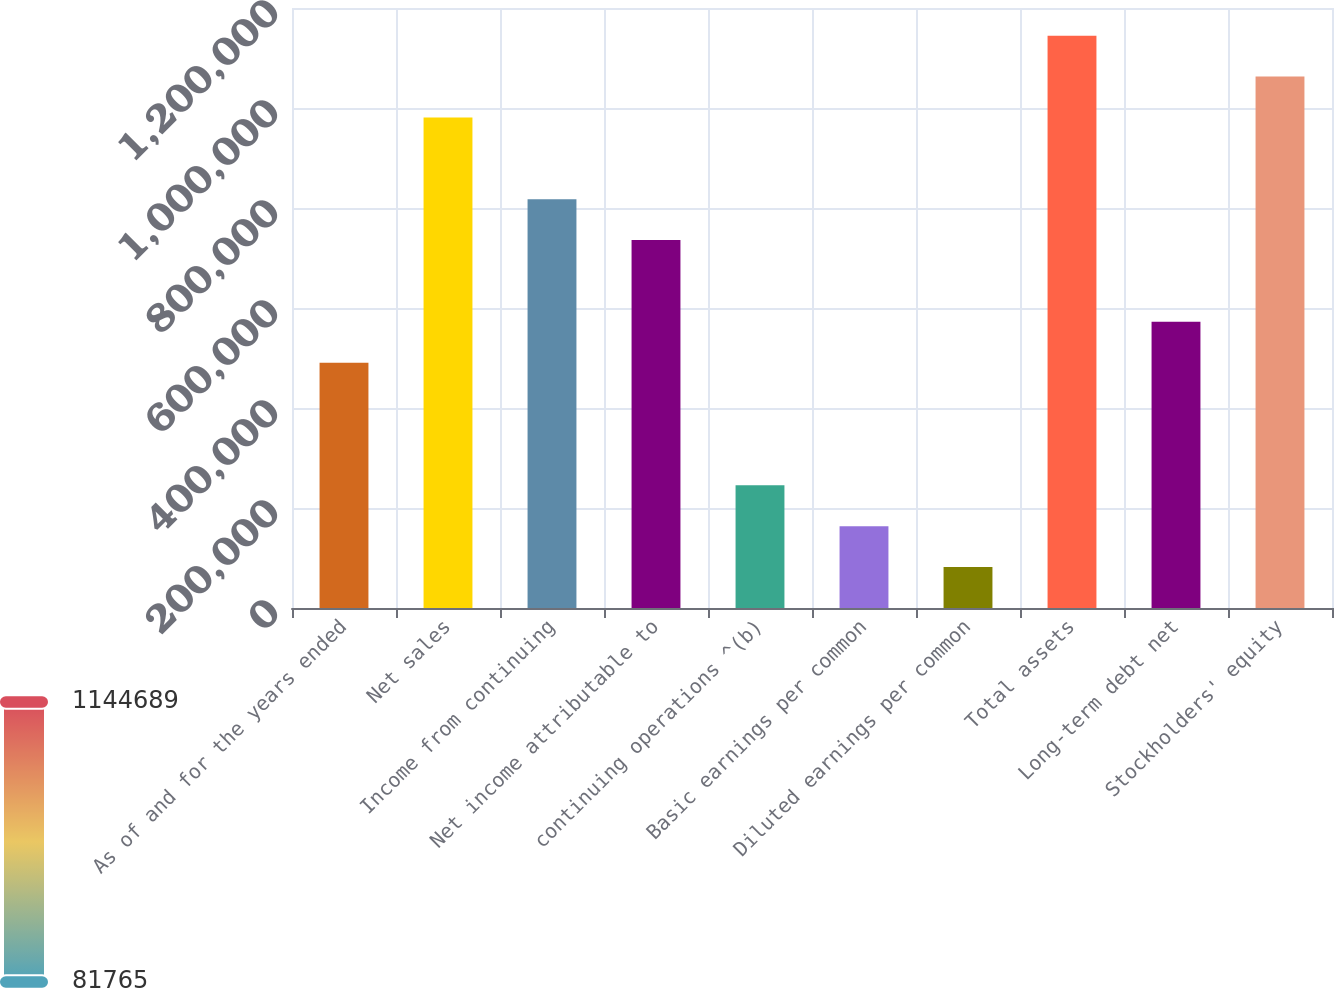<chart> <loc_0><loc_0><loc_500><loc_500><bar_chart><fcel>As of and for the years ended<fcel>Net sales<fcel>Income from continuing<fcel>Net income attributable to<fcel>continuing operations ^(b)<fcel>Basic earnings per common<fcel>Diluted earnings per common<fcel>Total assets<fcel>Long-term debt net<fcel>Stockholders' equity<nl><fcel>490581<fcel>981162<fcel>817635<fcel>735872<fcel>245291<fcel>163528<fcel>81764.6<fcel>1.14469e+06<fcel>572345<fcel>1.06293e+06<nl></chart> 